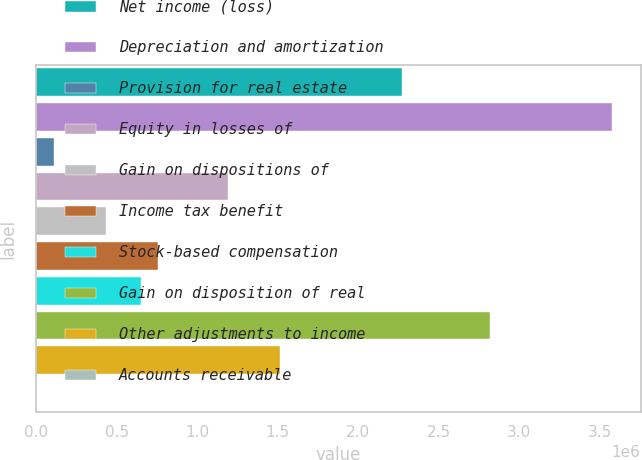Convert chart to OTSL. <chart><loc_0><loc_0><loc_500><loc_500><bar_chart><fcel>Net income (loss)<fcel>Depreciation and amortization<fcel>Provision for real estate<fcel>Equity in losses of<fcel>Gain on dispositions of<fcel>Income tax benefit<fcel>Stock-based compensation<fcel>Gain on disposition of real<fcel>Other adjustments to income<fcel>Accounts receivable<nl><fcel>2.27532e+06<fcel>3.57528e+06<fcel>108718<fcel>1.19202e+06<fcel>433709<fcel>758699<fcel>650369<fcel>2.81697e+06<fcel>1.51701e+06<fcel>388<nl></chart> 